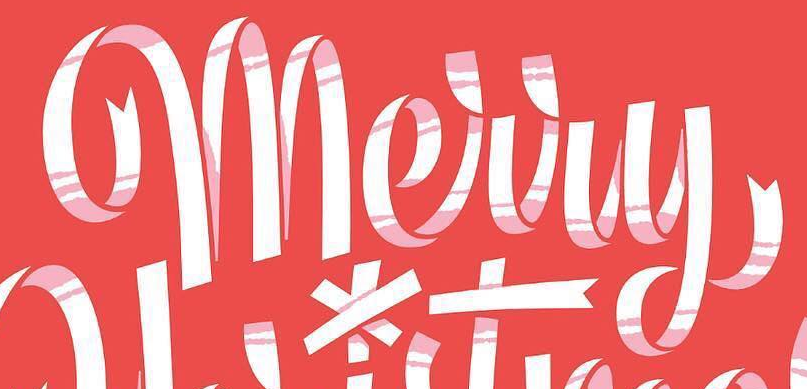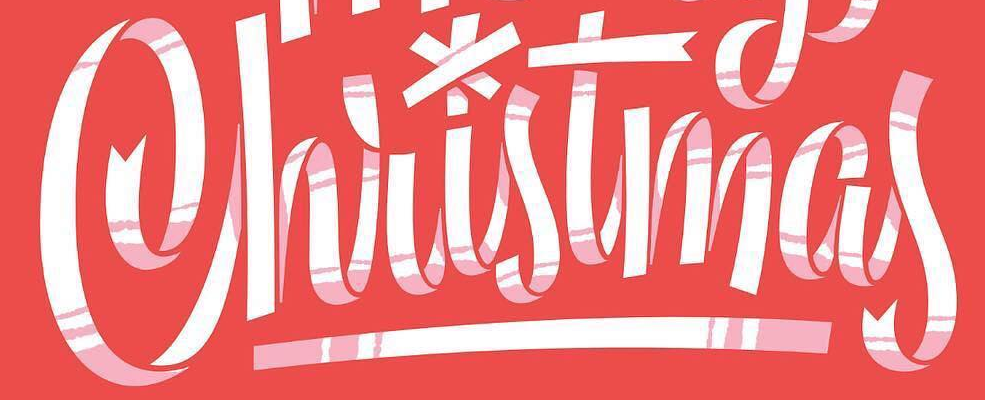Read the text content from these images in order, separated by a semicolon. Merry; Christmas 